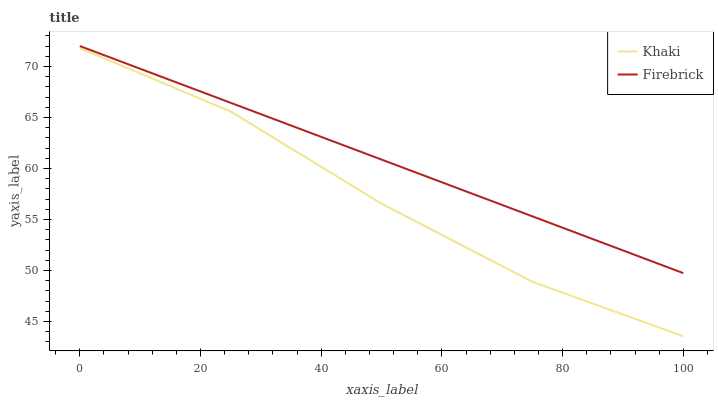Does Khaki have the minimum area under the curve?
Answer yes or no. Yes. Does Firebrick have the maximum area under the curve?
Answer yes or no. Yes. Does Khaki have the maximum area under the curve?
Answer yes or no. No. Is Firebrick the smoothest?
Answer yes or no. Yes. Is Khaki the roughest?
Answer yes or no. Yes. Is Khaki the smoothest?
Answer yes or no. No. Does Khaki have the lowest value?
Answer yes or no. Yes. Does Firebrick have the highest value?
Answer yes or no. Yes. Does Khaki have the highest value?
Answer yes or no. No. Is Khaki less than Firebrick?
Answer yes or no. Yes. Is Firebrick greater than Khaki?
Answer yes or no. Yes. Does Khaki intersect Firebrick?
Answer yes or no. No. 